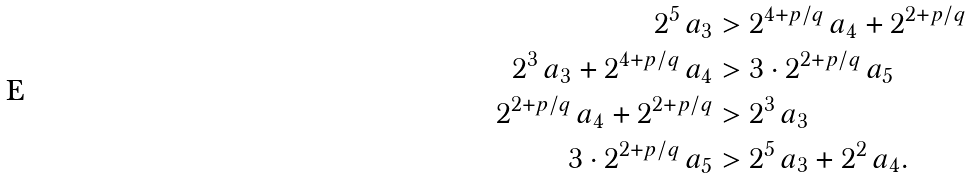<formula> <loc_0><loc_0><loc_500><loc_500>2 ^ { 5 } \, a _ { 3 } & > 2 ^ { 4 + p / q } \, a _ { 4 } + 2 ^ { 2 + p / q } \\ 2 ^ { 3 } \, a _ { 3 } + 2 ^ { 4 + p / q } \, a _ { 4 } & > 3 \cdot 2 ^ { 2 + p / q } \, a _ { 5 } \\ 2 ^ { 2 + p / q } \, a _ { 4 } + 2 ^ { 2 + p / q } & > 2 ^ { 3 } \, a _ { 3 } \\ 3 \cdot 2 ^ { 2 + p / q } \, a _ { 5 } & > 2 ^ { 5 } \, a _ { 3 } + 2 ^ { 2 } \, a _ { 4 } .</formula> 